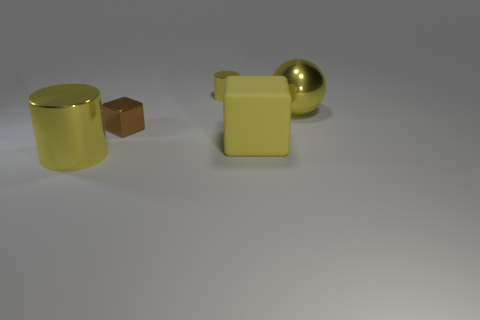Are there any rubber cubes of the same size as the sphere?
Your answer should be very brief. Yes. What material is the yellow cylinder behind the big metallic thing behind the yellow cylinder that is in front of the large yellow metallic sphere?
Ensure brevity in your answer.  Metal. There is a big yellow object that is on the right side of the yellow matte block; what number of small shiny cylinders are in front of it?
Your answer should be compact. 0. Does the cylinder that is in front of the yellow cube have the same size as the large shiny sphere?
Ensure brevity in your answer.  Yes. What number of small yellow metallic objects have the same shape as the tiny brown metallic thing?
Give a very brief answer. 0. What shape is the tiny yellow shiny thing?
Offer a terse response. Cylinder. Is the number of yellow objects in front of the big yellow metal cylinder the same as the number of large rubber objects?
Give a very brief answer. No. Is there any other thing that is the same material as the yellow cube?
Give a very brief answer. No. Are the tiny object that is in front of the yellow metal sphere and the big yellow ball made of the same material?
Provide a succinct answer. Yes. Is the number of yellow metallic cylinders to the right of the large cube less than the number of cylinders?
Provide a short and direct response. Yes. 